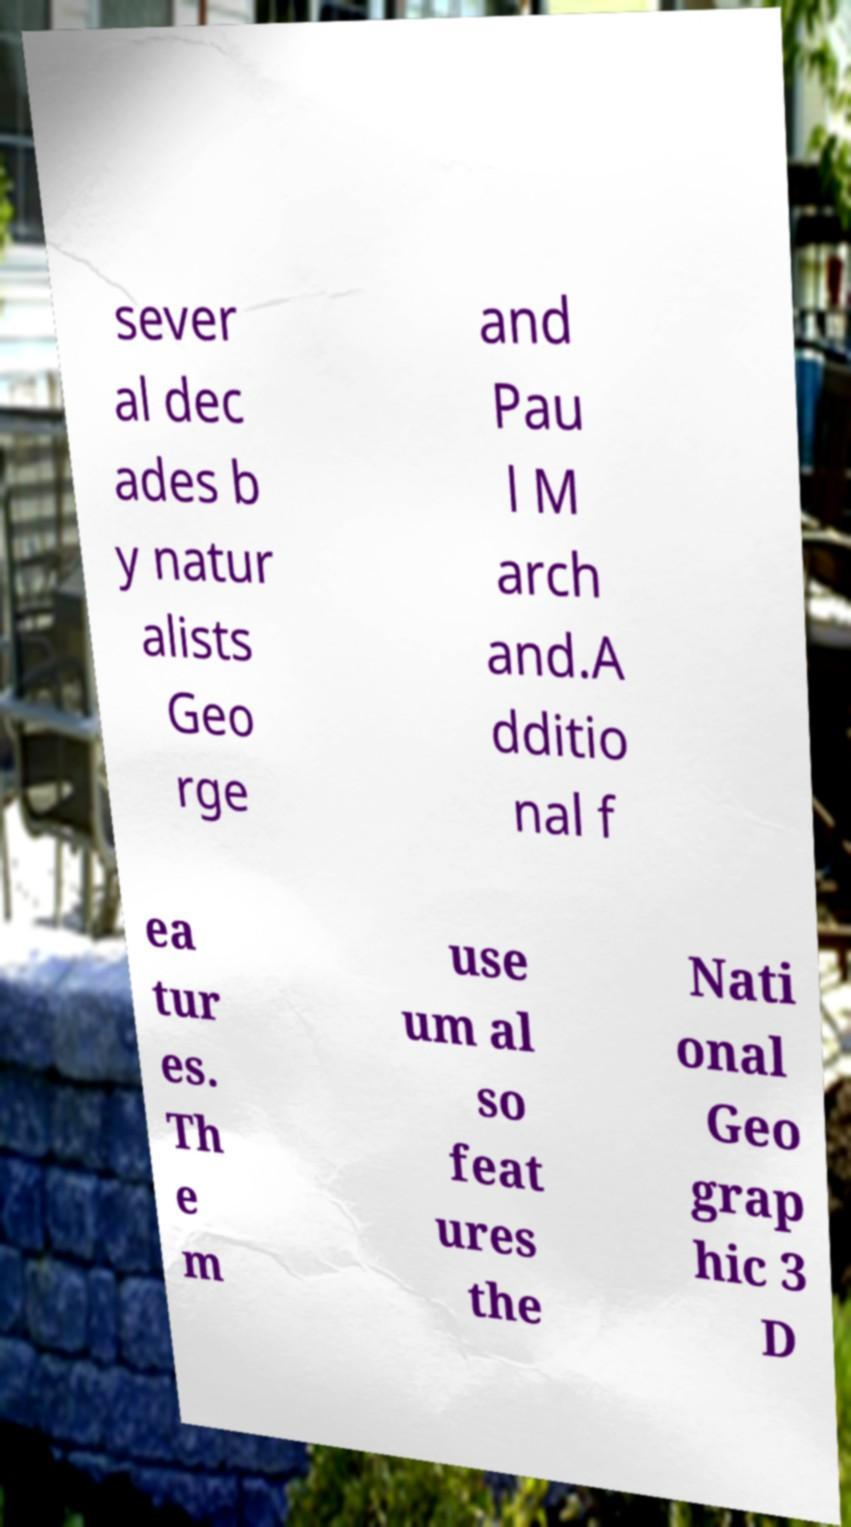What messages or text are displayed in this image? I need them in a readable, typed format. sever al dec ades b y natur alists Geo rge and Pau l M arch and.A dditio nal f ea tur es. Th e m use um al so feat ures the Nati onal Geo grap hic 3 D 